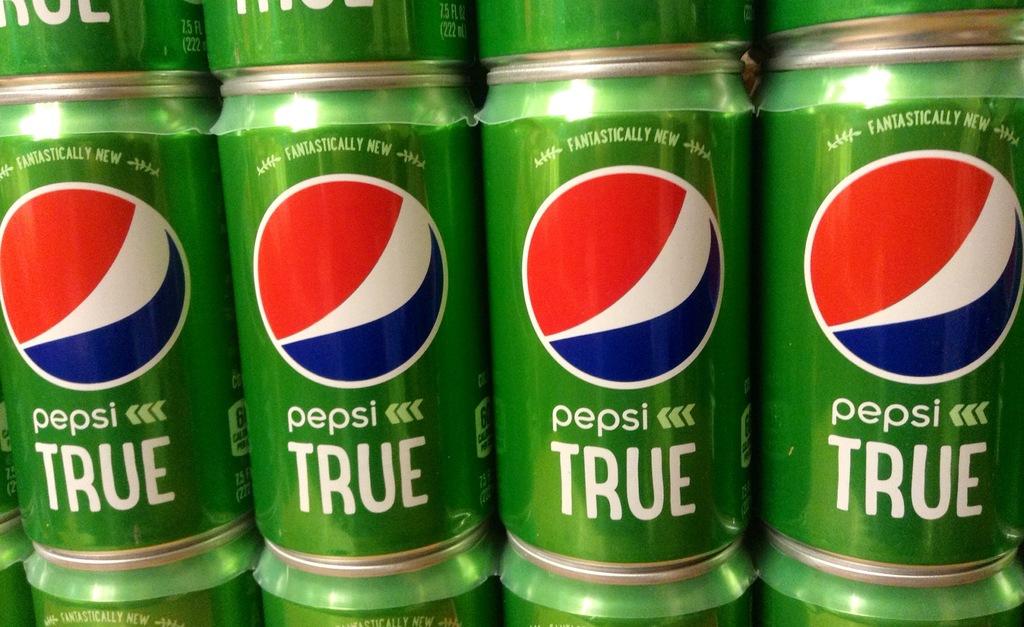What word is printed under the word "pepsi" on this green can?
Offer a very short reply. True. Is this new?
Your answer should be very brief. Yes. 